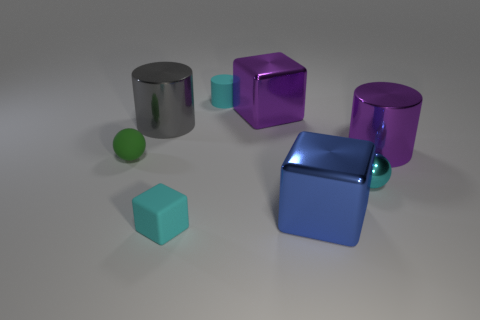Add 1 metal cylinders. How many objects exist? 9 Subtract all spheres. How many objects are left? 6 Subtract all matte things. Subtract all tiny gray metallic objects. How many objects are left? 5 Add 7 cyan cubes. How many cyan cubes are left? 8 Add 5 metallic things. How many metallic things exist? 10 Subtract 0 red cylinders. How many objects are left? 8 